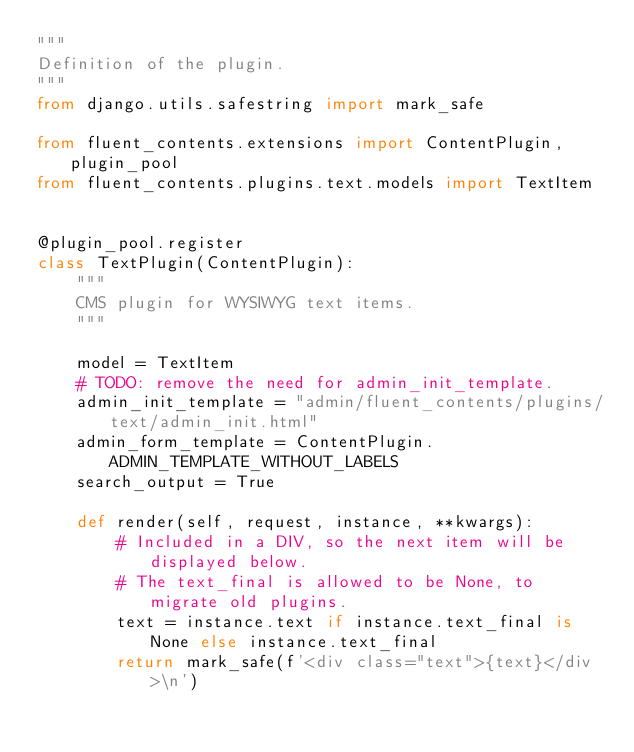Convert code to text. <code><loc_0><loc_0><loc_500><loc_500><_Python_>"""
Definition of the plugin.
"""
from django.utils.safestring import mark_safe

from fluent_contents.extensions import ContentPlugin, plugin_pool
from fluent_contents.plugins.text.models import TextItem


@plugin_pool.register
class TextPlugin(ContentPlugin):
    """
    CMS plugin for WYSIWYG text items.
    """

    model = TextItem
    # TODO: remove the need for admin_init_template.
    admin_init_template = "admin/fluent_contents/plugins/text/admin_init.html"
    admin_form_template = ContentPlugin.ADMIN_TEMPLATE_WITHOUT_LABELS
    search_output = True

    def render(self, request, instance, **kwargs):
        # Included in a DIV, so the next item will be displayed below.
        # The text_final is allowed to be None, to migrate old plugins.
        text = instance.text if instance.text_final is None else instance.text_final
        return mark_safe(f'<div class="text">{text}</div>\n')
</code> 